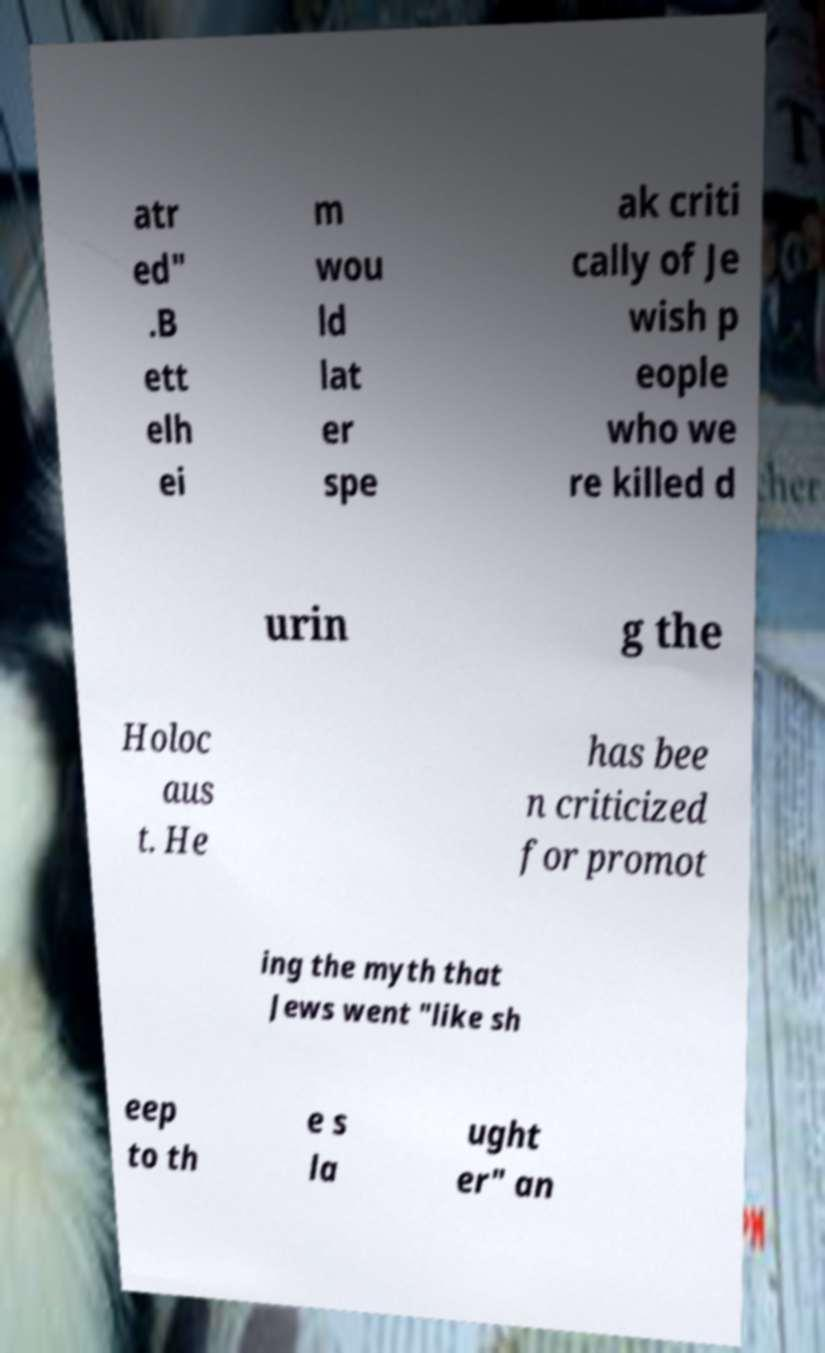What messages or text are displayed in this image? I need them in a readable, typed format. atr ed" .B ett elh ei m wou ld lat er spe ak criti cally of Je wish p eople who we re killed d urin g the Holoc aus t. He has bee n criticized for promot ing the myth that Jews went "like sh eep to th e s la ught er" an 